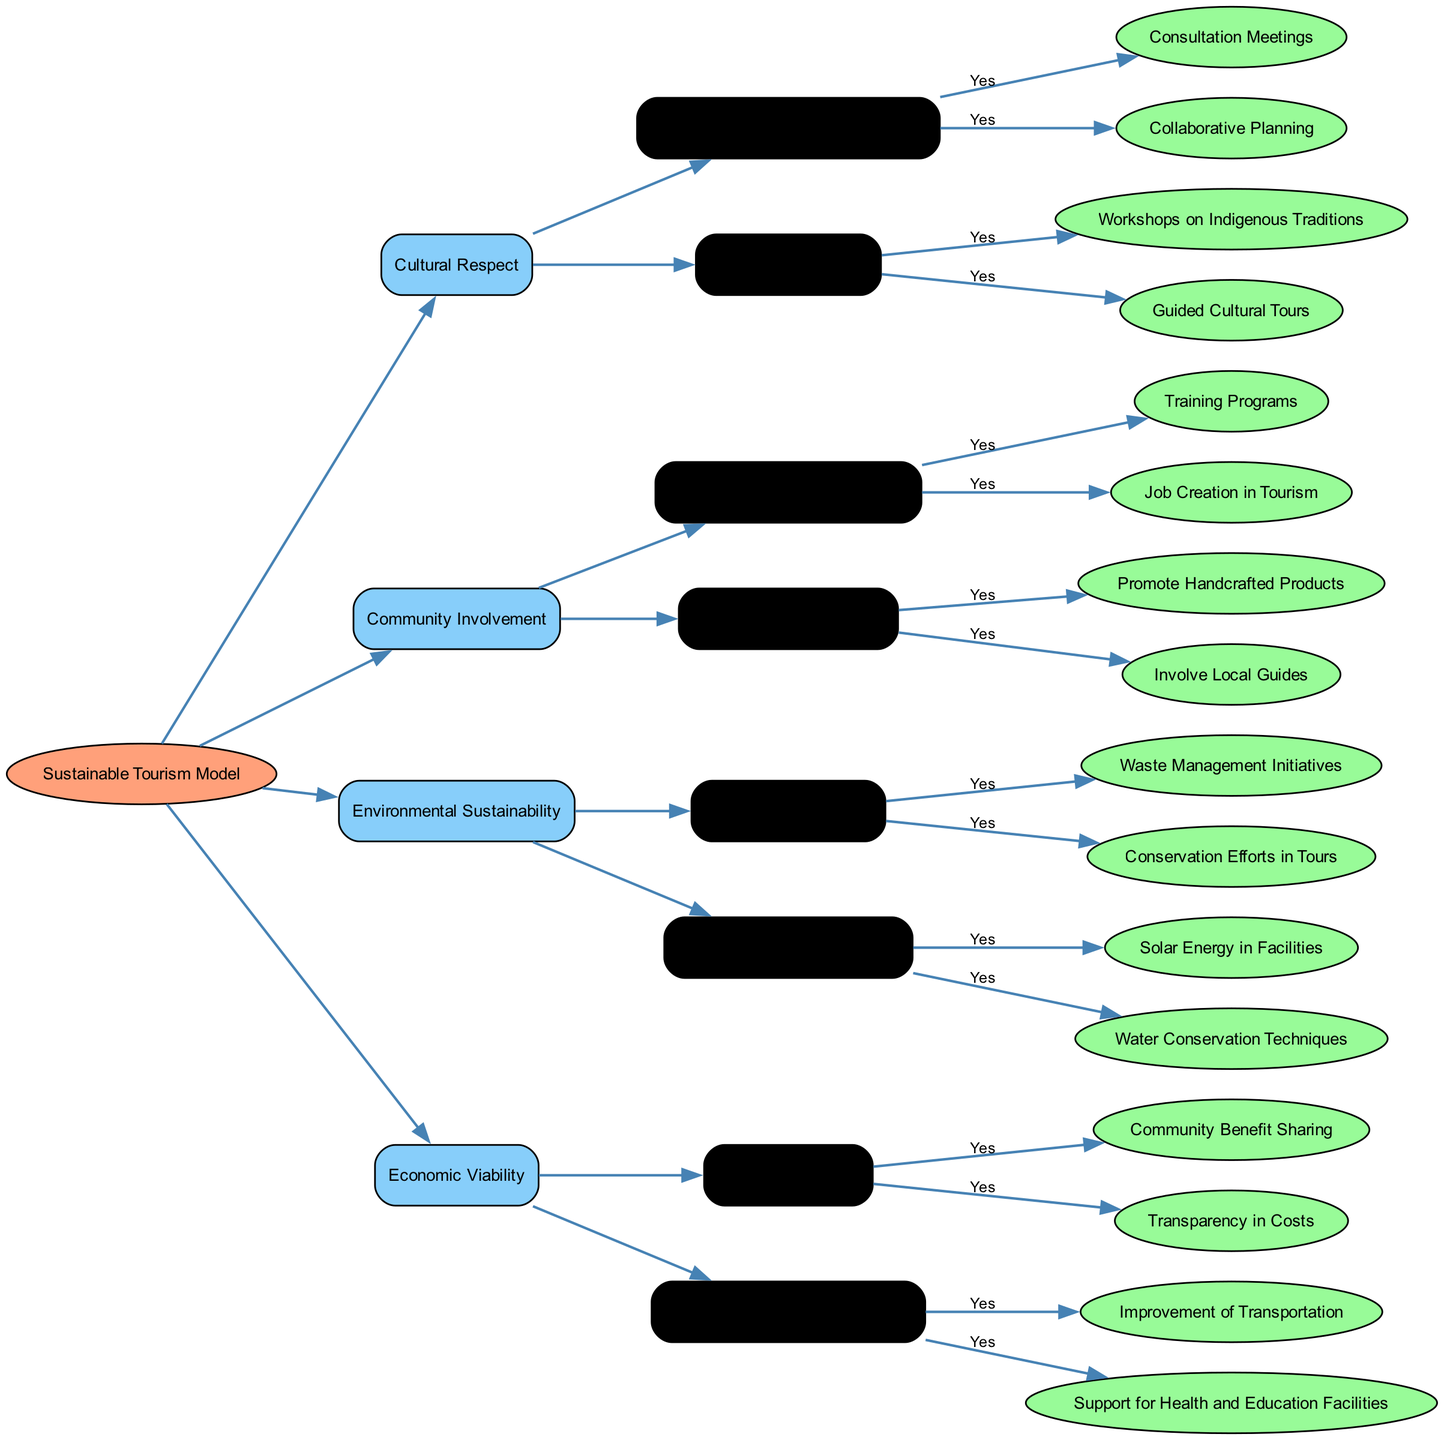What is the main purpose of the diagram? The main purpose of the diagram is to illustrate guidelines for developing a sustainable tourism model that respects indigenous heritage and promotes community involvement.
Answer: Sustainable tourism model How many main categories are there in the diagram? There are four main categories depicted in the diagram: Cultural Respect, Community Involvement, Environmental Sustainability, and Economic Viability. Counting these categories from the root node confirms this number.
Answer: Four Which category includes training programs? The category that includes training programs is Community Involvement. This is determined by tracing the connection from the root to find the specific subcategory under Local Employment Opportunities.
Answer: Community Involvement What type of practices are included under Environmental Sustainability? The types of practices included under Environmental Sustainability are Eco-Friendly Practices and Use of Renewable Resources. By following the nodes under this parent category, we see these two subcategories defined.
Answer: Eco-Friendly Practices and Use of Renewable Resources How many initiatives fall under Eco-Friendly Practices? There are two initiatives that fall under Eco-Friendly Practices: Waste Management Initiatives and Conservation Efforts in Tours. This count is determined by examining the leaf nodes that are direct children of Eco-Friendly Practices.
Answer: Two What is the relationship between Cultural Respect and Education for Visitors? The relationship is that Education for Visitors is a subcategory of Cultural Respect, meaning that it falls under the broader umbrella of Cultural Respect in the decision tree hierarchy.
Answer: Subcategory What is one way to support local businesses according to the diagram? One way to support local businesses is by promoting handcrafted products. This is explicitly listed as a strategy under the Support Local Businesses category in the diagram.
Answer: Promote Handcrafted Products How many actions are recommended for Waste Management Initiatives? There is one action recommended for Waste Management Initiatives, which is marked as a true initiative in the diagram. By analyzing the elements under Eco-Friendly Practices, we find this single action.
Answer: One Which node indicates community benefit sharing in the pricing models? The node that indicates community benefit sharing is Fair Pricing Models, specifically under the Community Benefit Sharing subcategory. This conclusion follows the path from the Economic Viability category to its respective subcategories.
Answer: Fair Pricing Models 